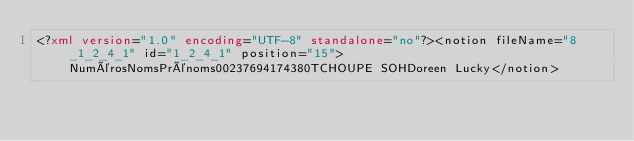<code> <loc_0><loc_0><loc_500><loc_500><_XML_><?xml version="1.0" encoding="UTF-8" standalone="no"?><notion fileName="8_1_2_4_1" id="1_2_4_1" position="15">NumérosNomsPrénoms00237694174380TCHOUPE SOHDoreen Lucky</notion></code> 